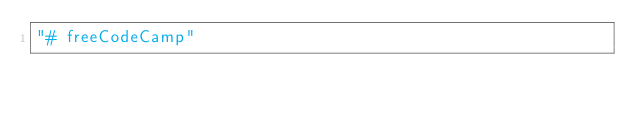Convert code to text. <code><loc_0><loc_0><loc_500><loc_500><_HTML_>"# freeCodeCamp" 
</code> 